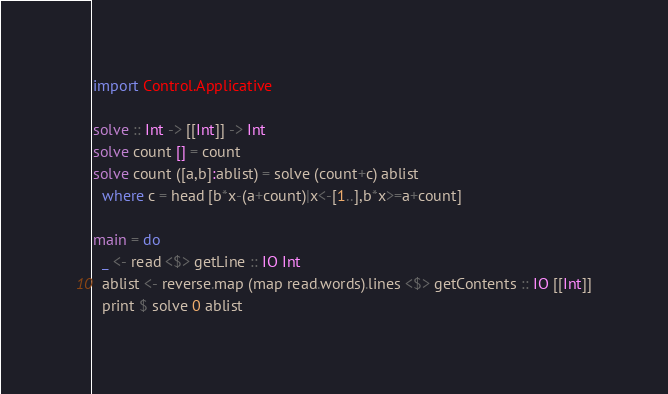<code> <loc_0><loc_0><loc_500><loc_500><_Haskell_>import Control.Applicative

solve :: Int -> [[Int]] -> Int
solve count [] = count
solve count ([a,b]:ablist) = solve (count+c) ablist
  where c = head [b*x-(a+count)|x<-[1..],b*x>=a+count]

main = do
  _ <- read <$> getLine :: IO Int
  ablist <- reverse.map (map read.words).lines <$> getContents :: IO [[Int]]
  print $ solve 0 ablist
</code> 